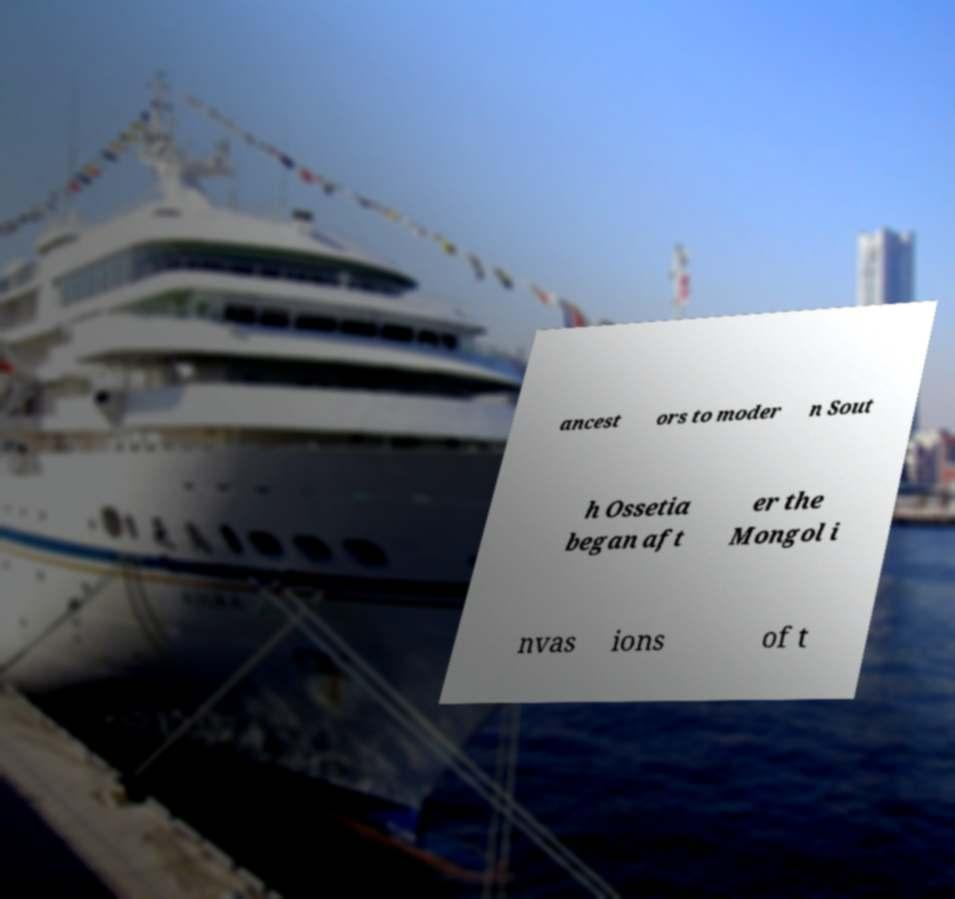Could you assist in decoding the text presented in this image and type it out clearly? ancest ors to moder n Sout h Ossetia began aft er the Mongol i nvas ions of t 